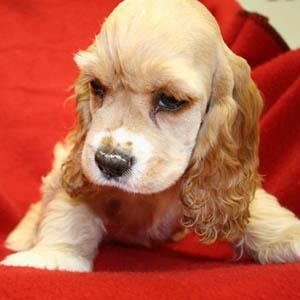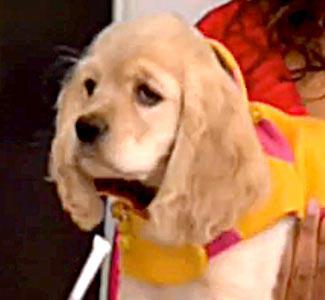The first image is the image on the left, the second image is the image on the right. Given the left and right images, does the statement "A spaniel dog is chewing on some object in one of the images." hold true? Answer yes or no. No. 